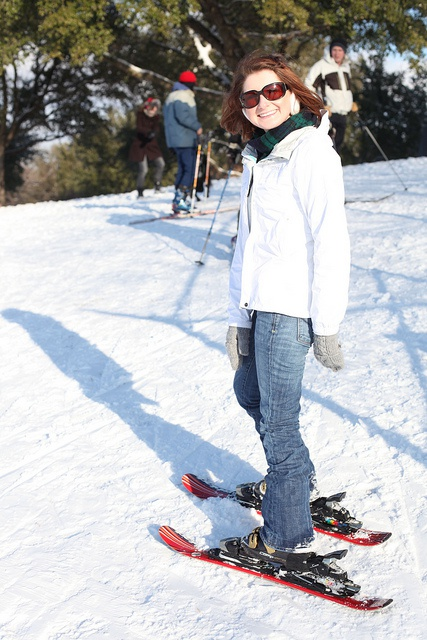Describe the objects in this image and their specific colors. I can see people in darkgreen, white, gray, and black tones, skis in darkgreen, black, lightgray, gray, and maroon tones, people in darkgreen, gray, navy, and black tones, people in darkgreen, ivory, black, darkgray, and gray tones, and people in darkgreen, black, gray, darkgray, and maroon tones in this image. 